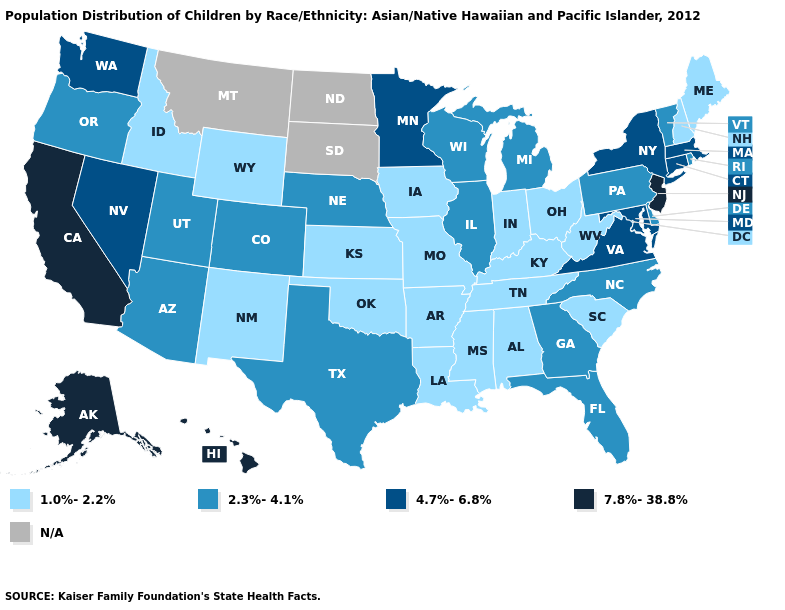Which states have the highest value in the USA?
Be succinct. Alaska, California, Hawaii, New Jersey. Among the states that border Oklahoma , does New Mexico have the lowest value?
Be succinct. Yes. Which states have the lowest value in the USA?
Answer briefly. Alabama, Arkansas, Idaho, Indiana, Iowa, Kansas, Kentucky, Louisiana, Maine, Mississippi, Missouri, New Hampshire, New Mexico, Ohio, Oklahoma, South Carolina, Tennessee, West Virginia, Wyoming. What is the value of New Jersey?
Give a very brief answer. 7.8%-38.8%. Which states have the highest value in the USA?
Be succinct. Alaska, California, Hawaii, New Jersey. How many symbols are there in the legend?
Quick response, please. 5. Name the states that have a value in the range 2.3%-4.1%?
Short answer required. Arizona, Colorado, Delaware, Florida, Georgia, Illinois, Michigan, Nebraska, North Carolina, Oregon, Pennsylvania, Rhode Island, Texas, Utah, Vermont, Wisconsin. Name the states that have a value in the range 1.0%-2.2%?
Quick response, please. Alabama, Arkansas, Idaho, Indiana, Iowa, Kansas, Kentucky, Louisiana, Maine, Mississippi, Missouri, New Hampshire, New Mexico, Ohio, Oklahoma, South Carolina, Tennessee, West Virginia, Wyoming. How many symbols are there in the legend?
Give a very brief answer. 5. What is the value of Montana?
Give a very brief answer. N/A. Does Florida have the lowest value in the South?
Concise answer only. No. Name the states that have a value in the range 2.3%-4.1%?
Keep it brief. Arizona, Colorado, Delaware, Florida, Georgia, Illinois, Michigan, Nebraska, North Carolina, Oregon, Pennsylvania, Rhode Island, Texas, Utah, Vermont, Wisconsin. Name the states that have a value in the range N/A?
Be succinct. Montana, North Dakota, South Dakota. 